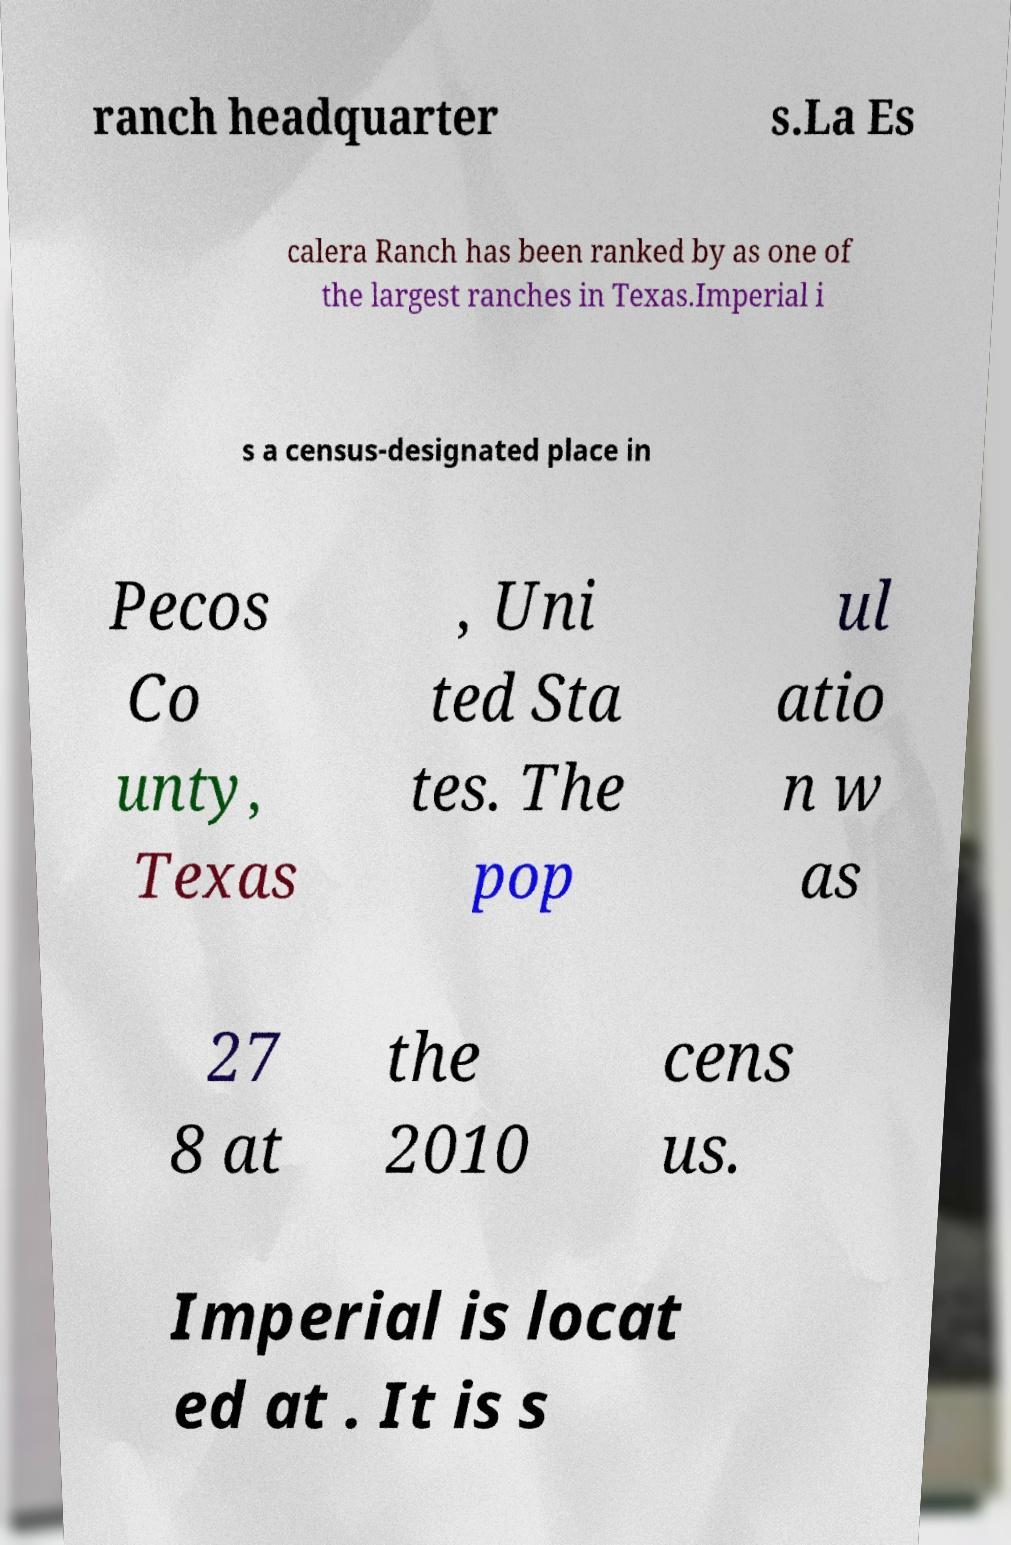Could you extract and type out the text from this image? ranch headquarter s.La Es calera Ranch has been ranked by as one of the largest ranches in Texas.Imperial i s a census-designated place in Pecos Co unty, Texas , Uni ted Sta tes. The pop ul atio n w as 27 8 at the 2010 cens us. Imperial is locat ed at . It is s 